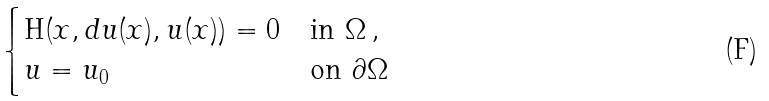<formula> <loc_0><loc_0><loc_500><loc_500>\begin{cases} { \mathrm H } ( x , d u ( x ) , u ( x ) ) = 0 & \text {in $\Omega$} \, , \\ u = u _ { 0 } & \text {on $\partial\Omega$} \end{cases}</formula> 